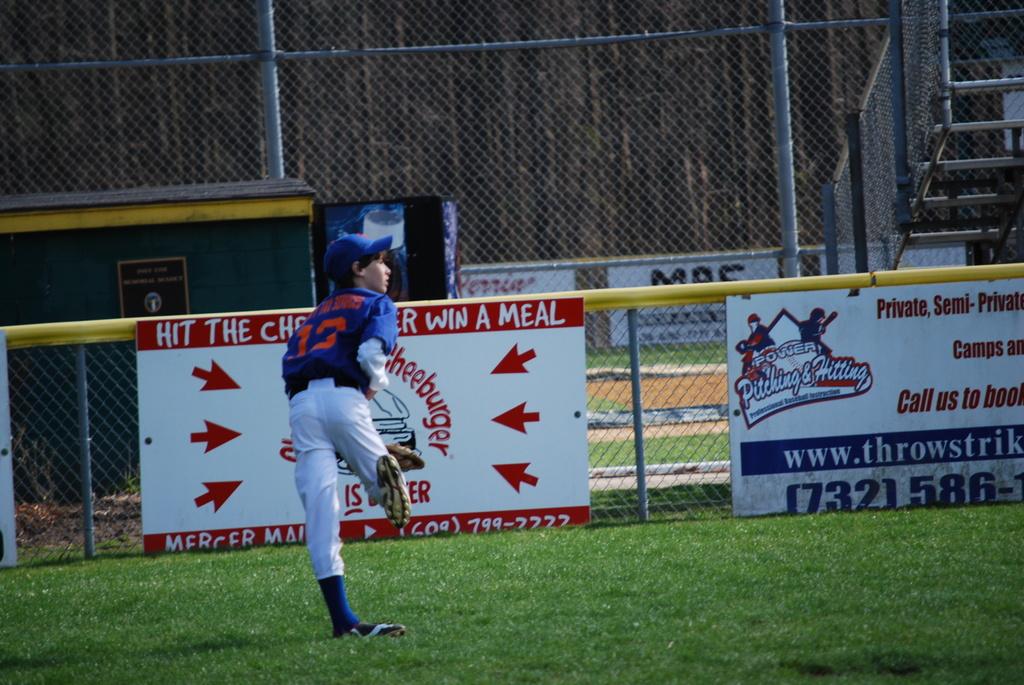What is his team number?
Your response must be concise. 13. 